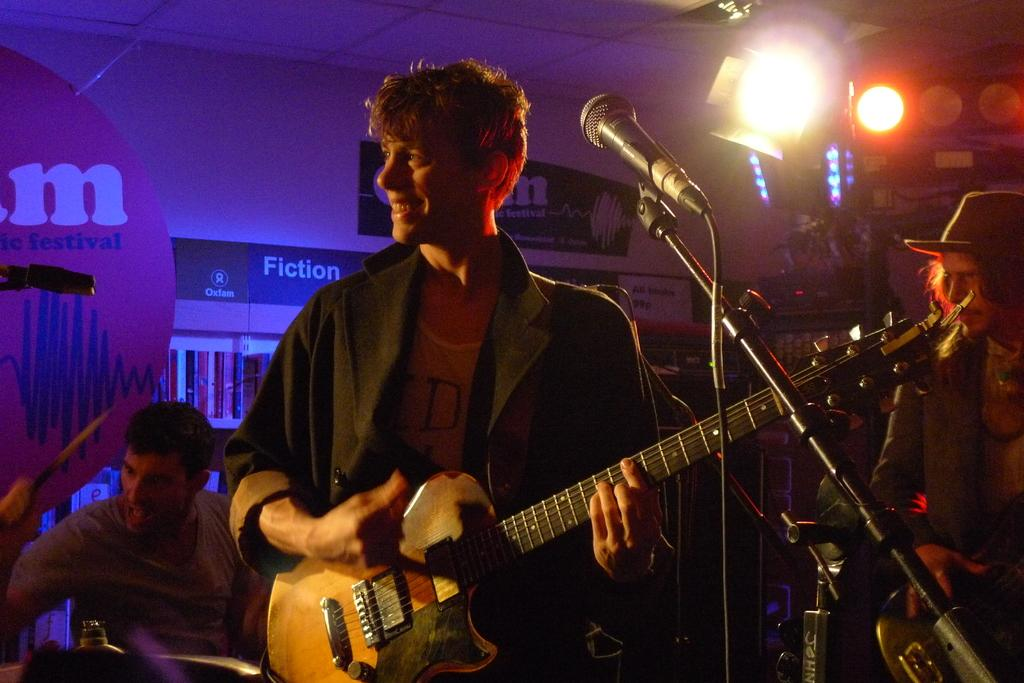How many people are in the image? There are people in the image, but the exact number is not specified. What is the man holding in the image? The man is holding a guitar in the image. What is the man's facial expression? The man has a smile on his face in the image. What object is present that is commonly used for amplifying sound? There is a microphone (mic) in the image. Can you see any wrens flying around in the image? There are no wrens present in the image. Is there a railway visible in the background of the image? There is no mention of a railway in the provided facts, so it cannot be determined if one is present in the image. 